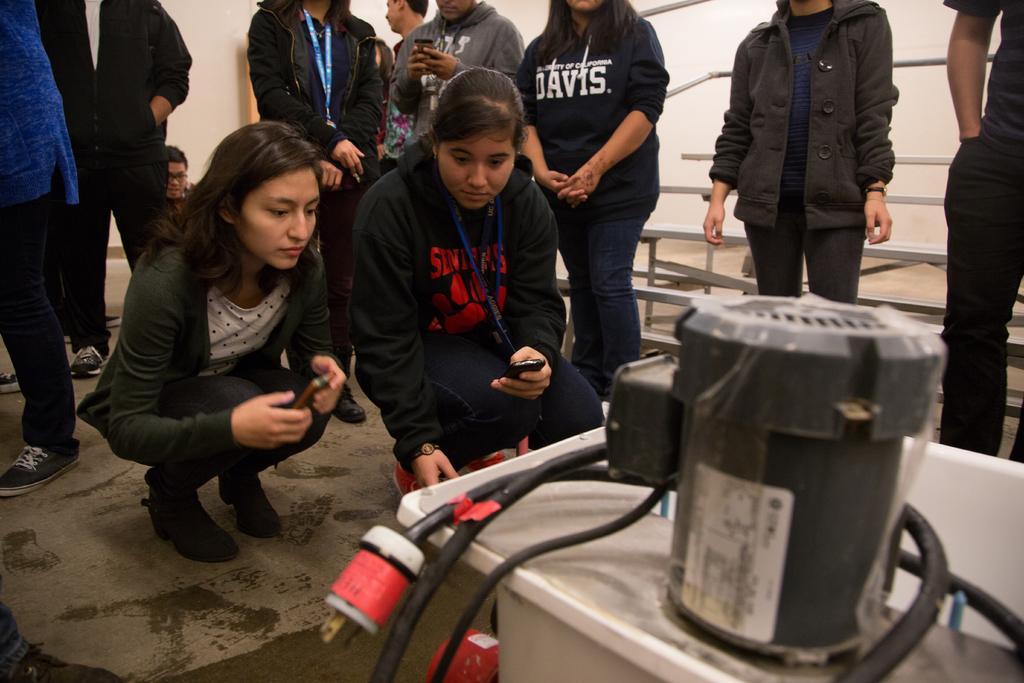In one or two sentences, can you explain what this image depicts? In this image I can see a woman wearing green jacket, white shirt, black pant and black shoe is sitting and another woman wearing black jacket, jeans and red shoe is sitting and I can see a electric equipment which is white, black and red in color in front of them. In the background I can see few other persons standing, few benches and the wall which is white in color. 